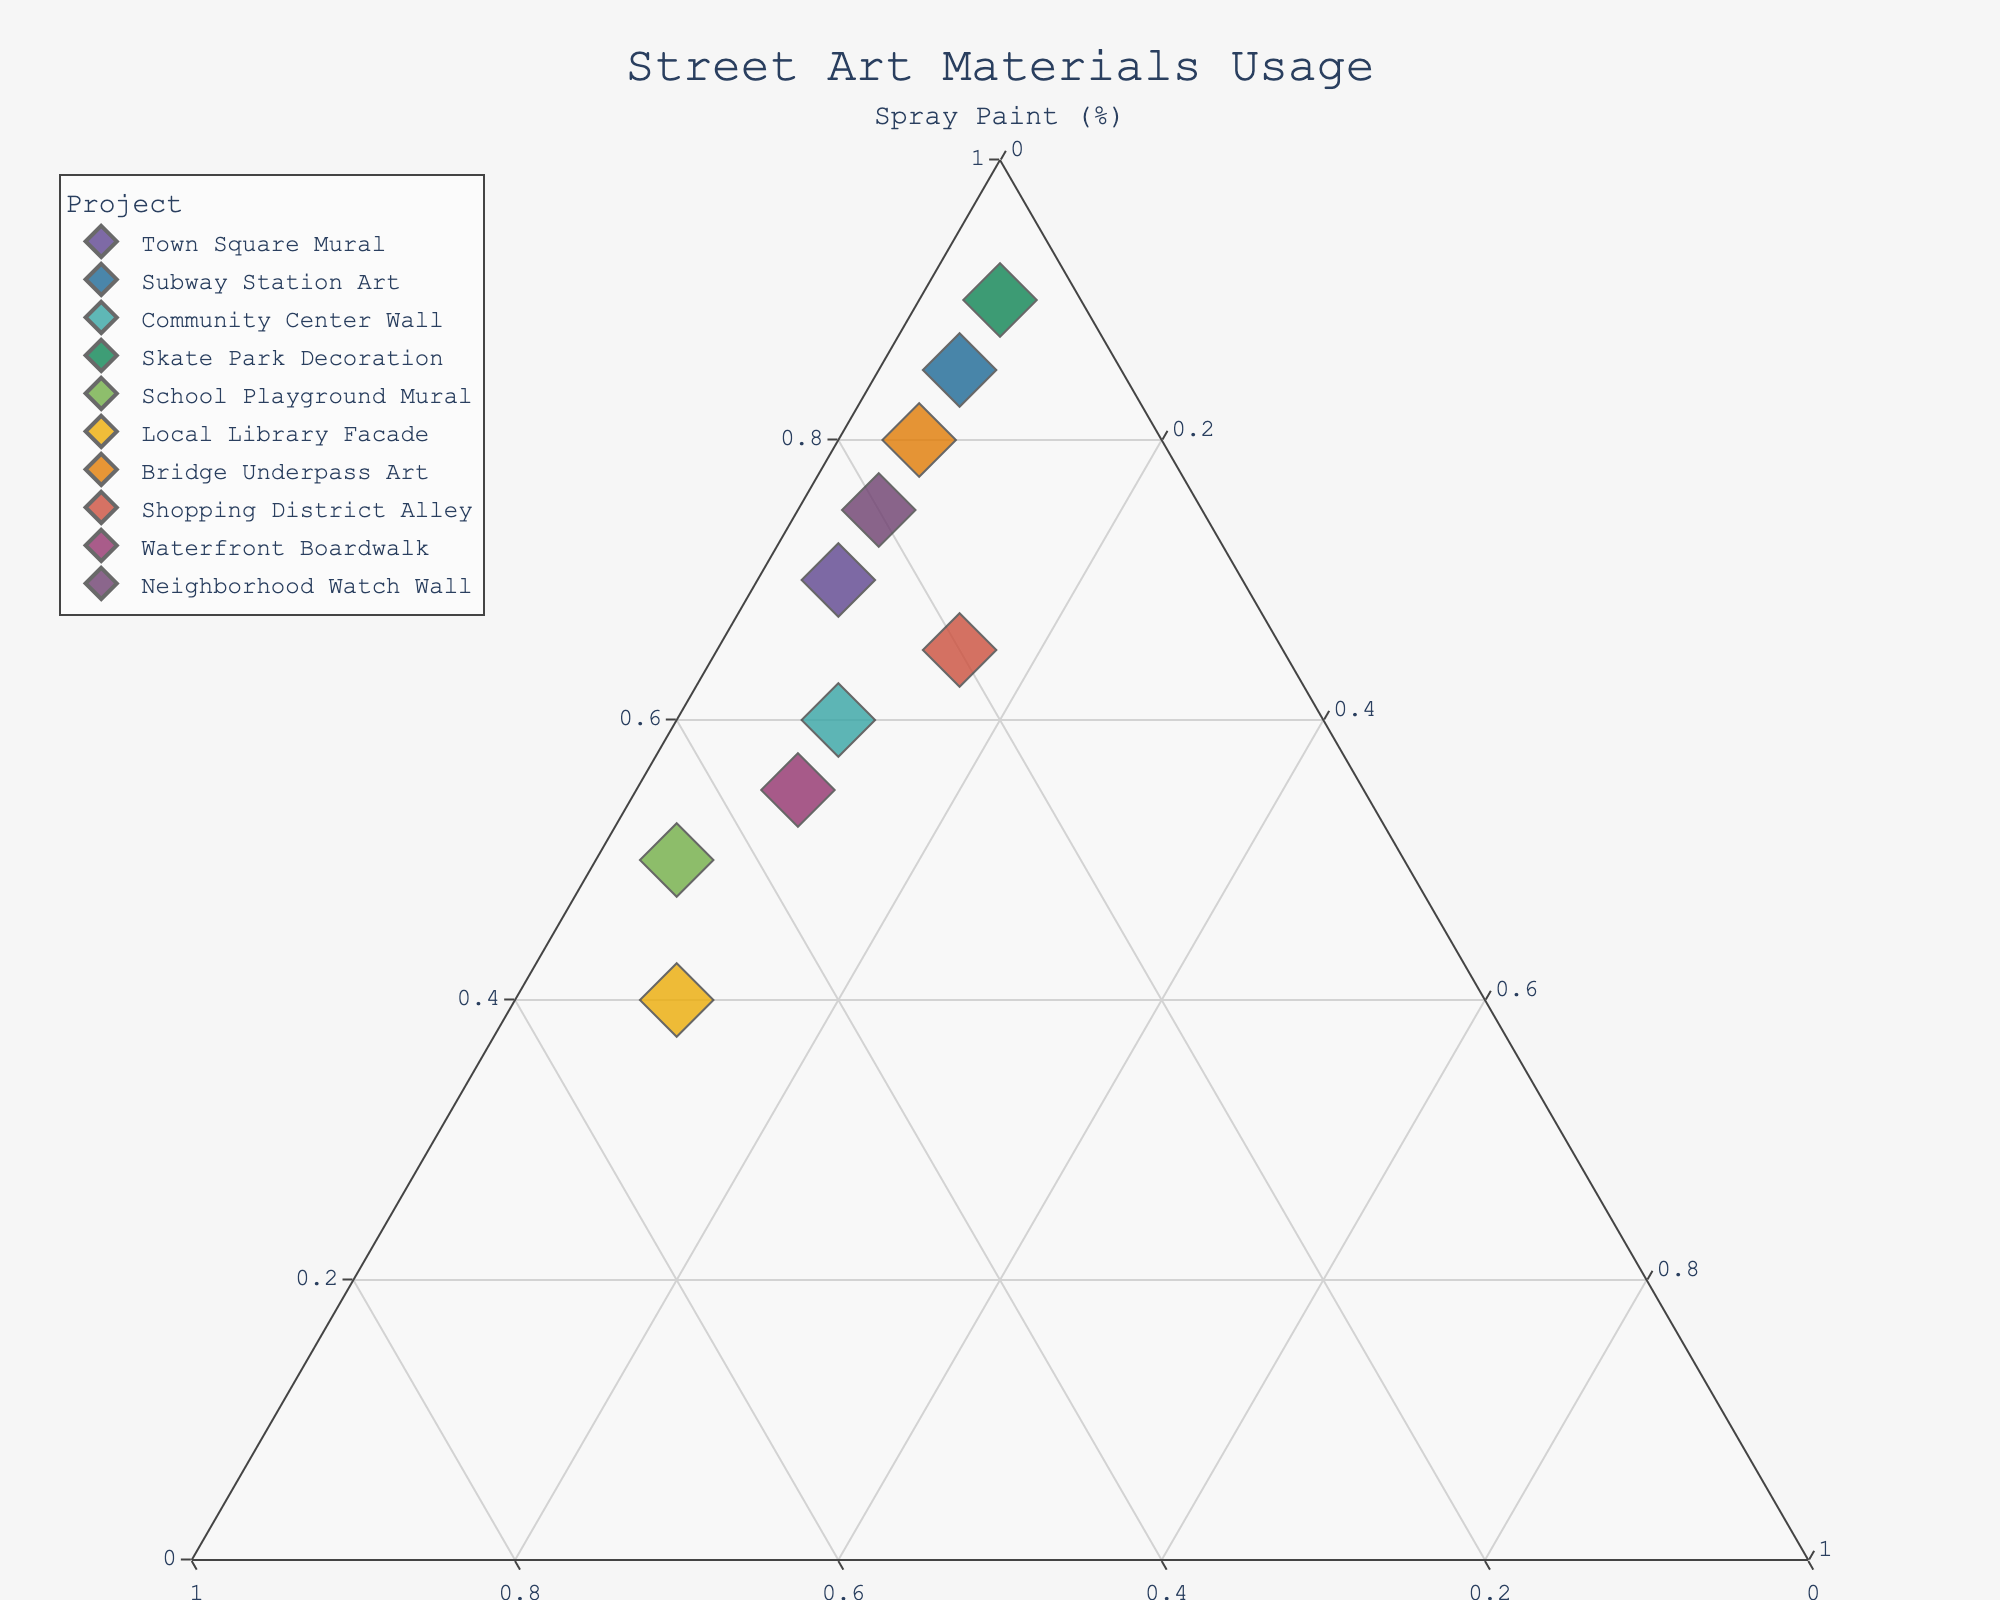What is the title of the plot? The title is usually displayed at the top of the plot. It gives an overarching description of what the plot represents and is essential for understanding the context of the data.
Answer: Street Art Materials Usage How many projects are represented in this ternary plot? By counting the markers (diamonds) on the plot, each representing a project, we can determine the number of projects illustrated in the figure.
Answer: 10 Which project used the highest proportion of spray paint? Identify the marker that is closest to the "Spray Paint" apex of the ternary plot. The closer the marker is to this apex, the higher the percentage of spray paint used in the project.
Answer: Skate Park Decoration Which project has the equal proportion of Wheat Paste and Acrylic? Locate the marker where the proportions of Wheat Paste and Acrylic are equal by finding the position exactly halfway between the Wheat Paste and Acrylic axes. The hover name or label provides the specific project name.
Answer: None What is the difference in the proportion of Acrylic between the Town Square Mural and the School Playground Mural? Look at the points representing the Town Square Mural and School Playground Mural, and note their positions along the Acrylic axis. Subtract the smaller proportion from the larger one to find the difference.
Answer: 20% Which project used a higher proportion of Wheat Paste: Community Center Wall or Waterfront Boardwalk? Compare the positions of the Community Center Wall and Waterfront Boardwalk markers along the Wheat Paste axis. The marker closer to the Wheat Paste apex represents the project with higher usage.
Answer: Waterfront Boardwalk What is the combined proportion of Acrylic and Wheat Paste used in the Local Library Facade project? Find the Local Library Facade marker and note the percentages of Acrylic and Wheat Paste. Add these two values together to get the combined proportion.
Answer: 60% Which project has the lowest usage of Acrylic? Identify the marker that is furthest from the Acrylic axis. The marker closest to the line connecting the Spray Paint and Wheat Paste apexes represents the project with the lowest Acrylic usage.
Answer: Skate Park Decoration Which two projects have the most similar proportions of materials used? Evaluate the positions of all markers to identify the two that are closest to each other, indicating similar proportions of Spray Paint, Acrylic, and Wheat Paste.
Answer: Neighborhood Watch Wall and Town Square Mural If a project used 45% Acrylic, 10% Wheat Paste, and the rest Spray Paint, where would it be located on the ternary plot? To determine a project's location, map the given proportions as coordinates on the ternary plot, taking care to ensure the total proportions add up to 100%. This new marker would fall within the appropriate region defined by these values.
Answer: Near the Local Library Facade 